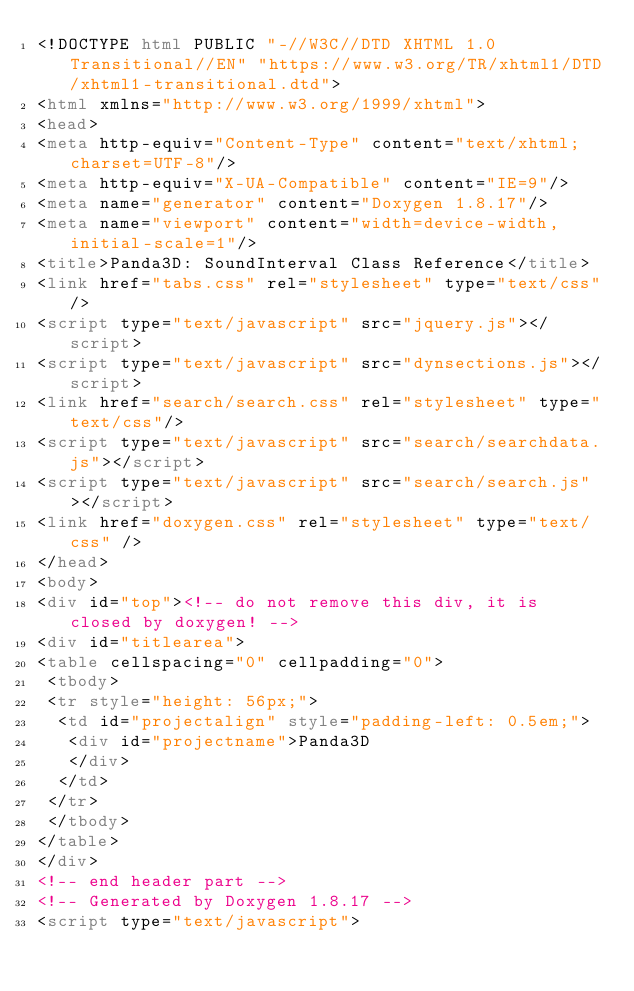<code> <loc_0><loc_0><loc_500><loc_500><_HTML_><!DOCTYPE html PUBLIC "-//W3C//DTD XHTML 1.0 Transitional//EN" "https://www.w3.org/TR/xhtml1/DTD/xhtml1-transitional.dtd">
<html xmlns="http://www.w3.org/1999/xhtml">
<head>
<meta http-equiv="Content-Type" content="text/xhtml;charset=UTF-8"/>
<meta http-equiv="X-UA-Compatible" content="IE=9"/>
<meta name="generator" content="Doxygen 1.8.17"/>
<meta name="viewport" content="width=device-width, initial-scale=1"/>
<title>Panda3D: SoundInterval Class Reference</title>
<link href="tabs.css" rel="stylesheet" type="text/css"/>
<script type="text/javascript" src="jquery.js"></script>
<script type="text/javascript" src="dynsections.js"></script>
<link href="search/search.css" rel="stylesheet" type="text/css"/>
<script type="text/javascript" src="search/searchdata.js"></script>
<script type="text/javascript" src="search/search.js"></script>
<link href="doxygen.css" rel="stylesheet" type="text/css" />
</head>
<body>
<div id="top"><!-- do not remove this div, it is closed by doxygen! -->
<div id="titlearea">
<table cellspacing="0" cellpadding="0">
 <tbody>
 <tr style="height: 56px;">
  <td id="projectalign" style="padding-left: 0.5em;">
   <div id="projectname">Panda3D
   </div>
  </td>
 </tr>
 </tbody>
</table>
</div>
<!-- end header part -->
<!-- Generated by Doxygen 1.8.17 -->
<script type="text/javascript"></code> 